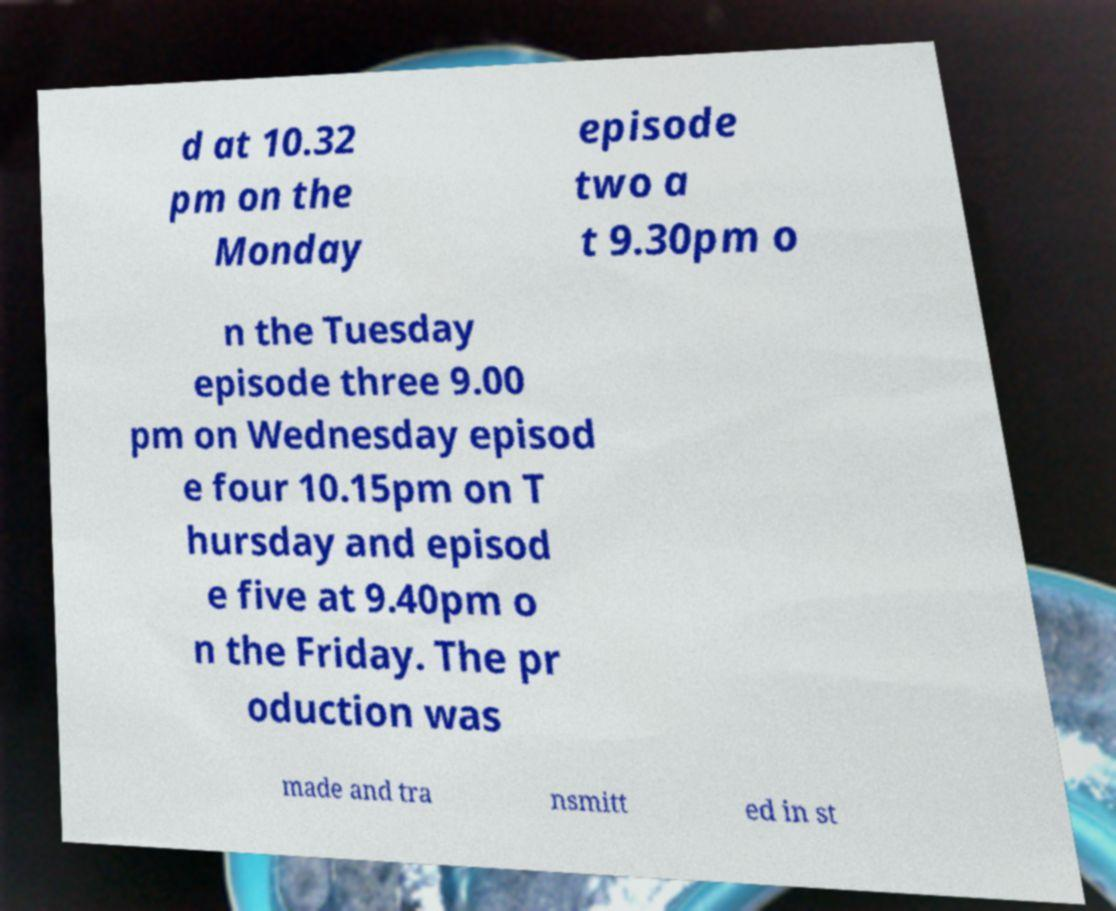I need the written content from this picture converted into text. Can you do that? d at 10.32 pm on the Monday episode two a t 9.30pm o n the Tuesday episode three 9.00 pm on Wednesday episod e four 10.15pm on T hursday and episod e five at 9.40pm o n the Friday. The pr oduction was made and tra nsmitt ed in st 